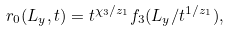Convert formula to latex. <formula><loc_0><loc_0><loc_500><loc_500>r _ { 0 } ( L _ { y } , t ) = t ^ { \chi _ { 3 } / z _ { 1 } } f _ { 3 } ( L _ { y } / t ^ { 1 / z _ { 1 } } ) ,</formula> 